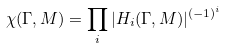<formula> <loc_0><loc_0><loc_500><loc_500>\chi ( \Gamma , M ) = \prod _ { i } | H _ { i } ( \Gamma , M ) | ^ { ( - 1 ) ^ { i } }</formula> 